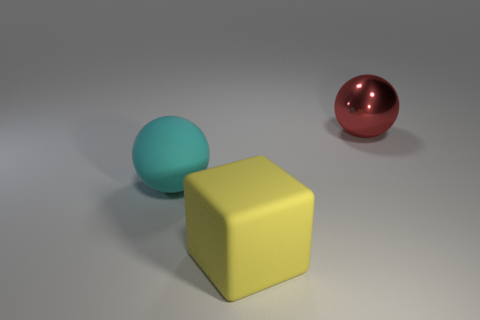Add 3 big red spheres. How many objects exist? 6 Subtract all red spheres. How many spheres are left? 1 Subtract all blue cylinders. How many red balls are left? 1 Subtract all purple blocks. Subtract all red spheres. How many blocks are left? 1 Subtract all cubes. How many objects are left? 2 Subtract 1 spheres. How many spheres are left? 1 Add 2 metal objects. How many metal objects exist? 3 Subtract 1 yellow cubes. How many objects are left? 2 Subtract all yellow rubber cubes. Subtract all large green blocks. How many objects are left? 2 Add 3 spheres. How many spheres are left? 5 